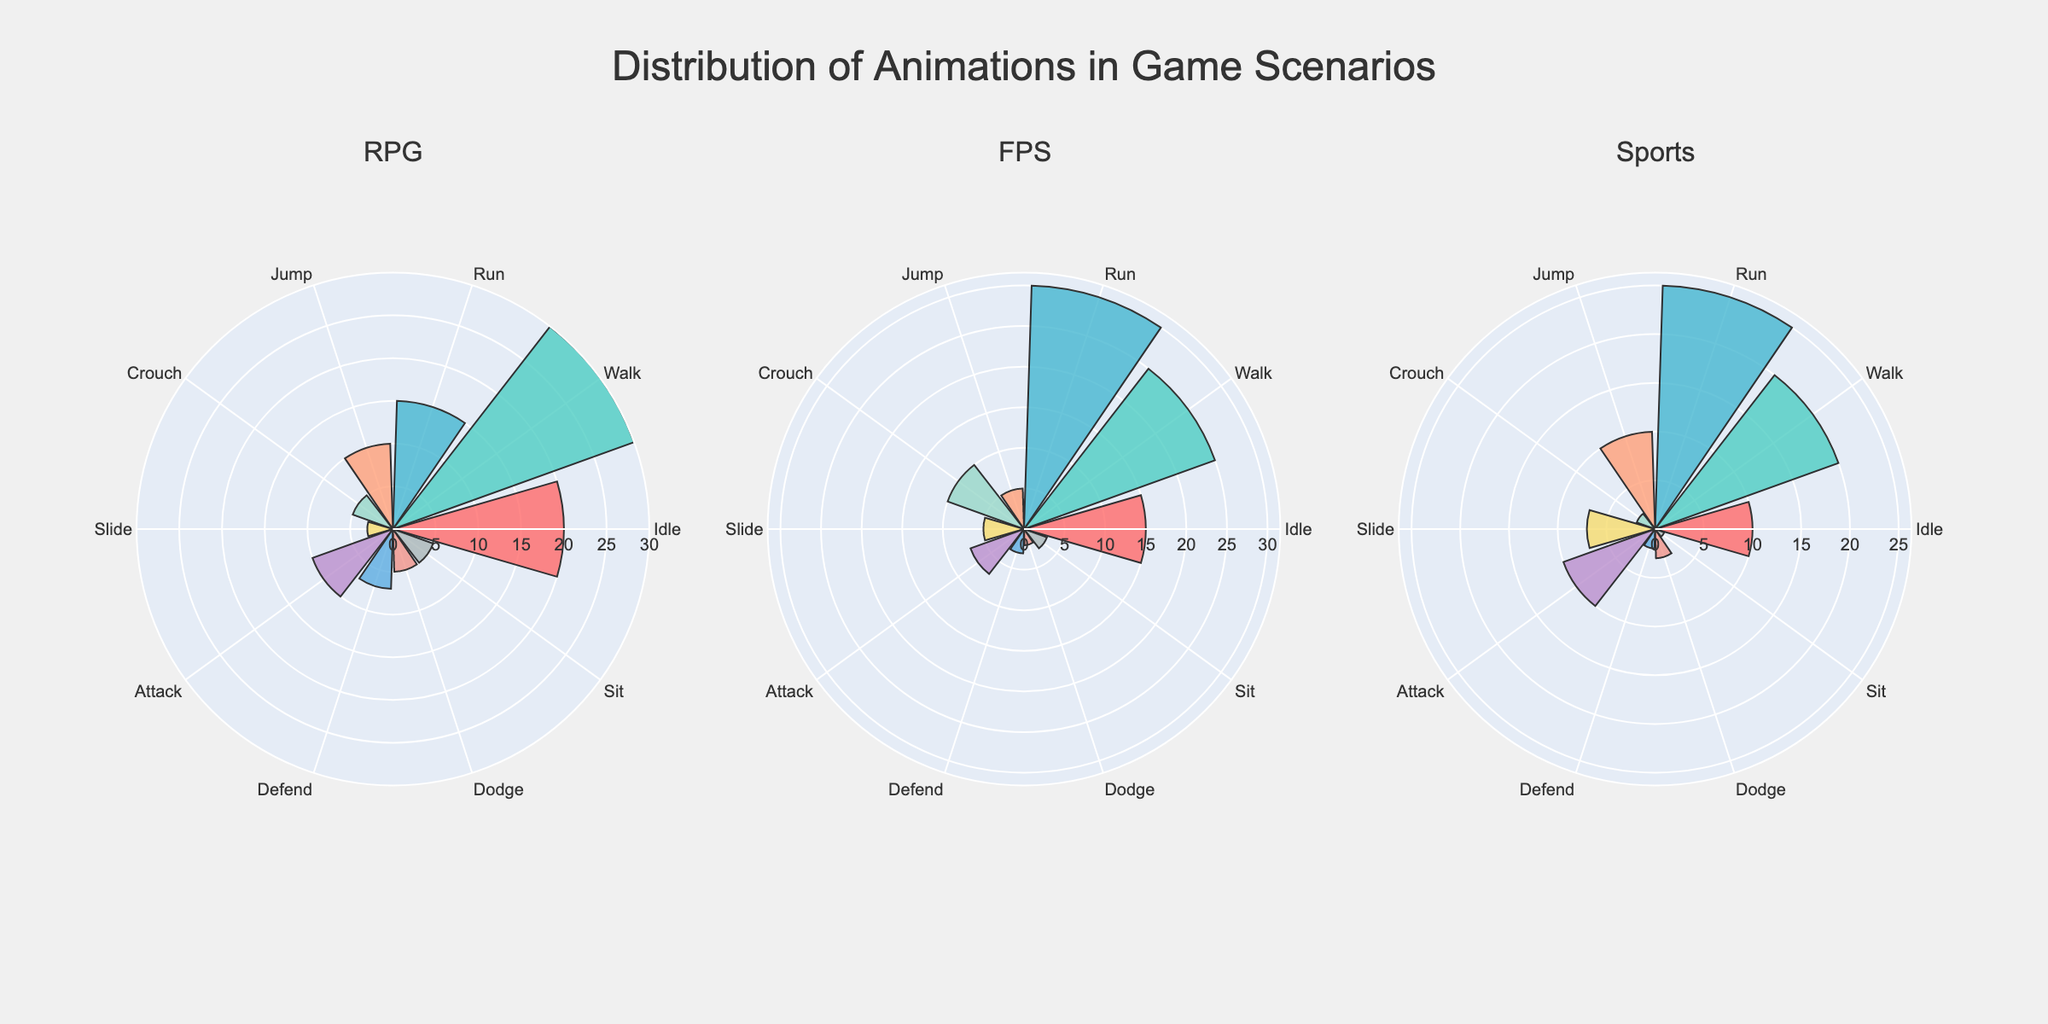What is the title of the figure? The title of the figure is located at the top center of the visual.
Answer: Distribution of Animations in Game Scenarios Which scenario has the highest percentage of 'Walk' animation? To determine this, look at the 'Walk' animation (Forward Movement) for all game types.
Answer: RPG What is the combined percentage of 'Idle' and 'Run' animations in the FPS scenario? Sum the percentages of 'Idle' and 'Run' under the FPS scenario column: 15% (Idle) + 30% (Run).
Answer: 45% Which animation has the lowest percentage in the Sports scenario? Look for the smallest value in the Sports scenario column.
Answer: Sit How do the distributions of 'Crouch' animation compare across RPG and FPS scenarios? Compare the percentages of 'Crouch' animation between RPG and FPS scenarios: 5% (RPG) vs 10% (FPS).
Answer: FPS is higher Compare the distribution of 'Dodge' animation in RPG and Sports scenarios. Which is higher? Check the percentage values for 'Dodge' animation in RPG and Sports scenarios: 5% (RPG) vs 3% (Sports).
Answer: RPG What is the difference in the percentage of 'Attack' animation between RPG and Sports scenarios? Subtract the percentage of 'Attack' animation in Sports scenario from RPG scenario: 10% (RPG) - 10% (Sports).
Answer: 0% Which scenario shows a higher variety in the animation distribution? Observe the range of values for each scenario and identify the one with the widest range.
Answer: FPS What is the average percentage of 'Jump' animations across all scenarios? Calculate the average by summing the percentages of 'Jump' in all scenarios and dividing by the number of scenarios: (10 + 5 + 10) / 3.
Answer: 8.33% How frequently is 'Defend' used in each of the scenarios as a percentage? Look at the percentage values of 'Defend' in all scenario columns: 7% (RPG), 3% (FPS), 2% (Sports).
Answer: RPG: 7%, FPS: 3%, Sports: 2% 